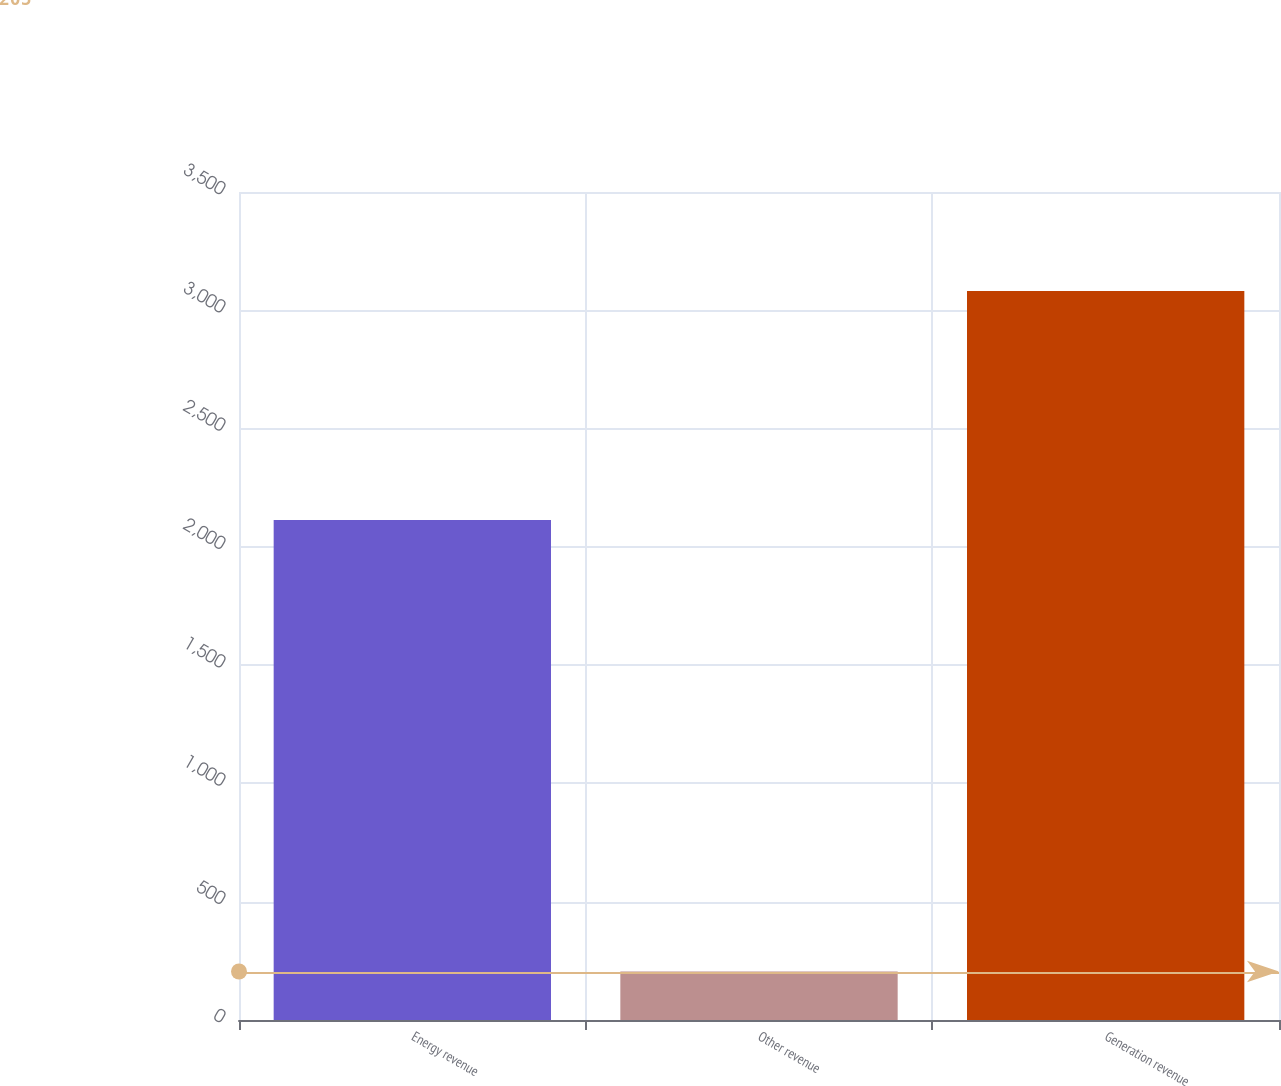Convert chart. <chart><loc_0><loc_0><loc_500><loc_500><bar_chart><fcel>Energy revenue<fcel>Other revenue<fcel>Generation revenue<nl><fcel>2114<fcel>205<fcel>3081<nl></chart> 